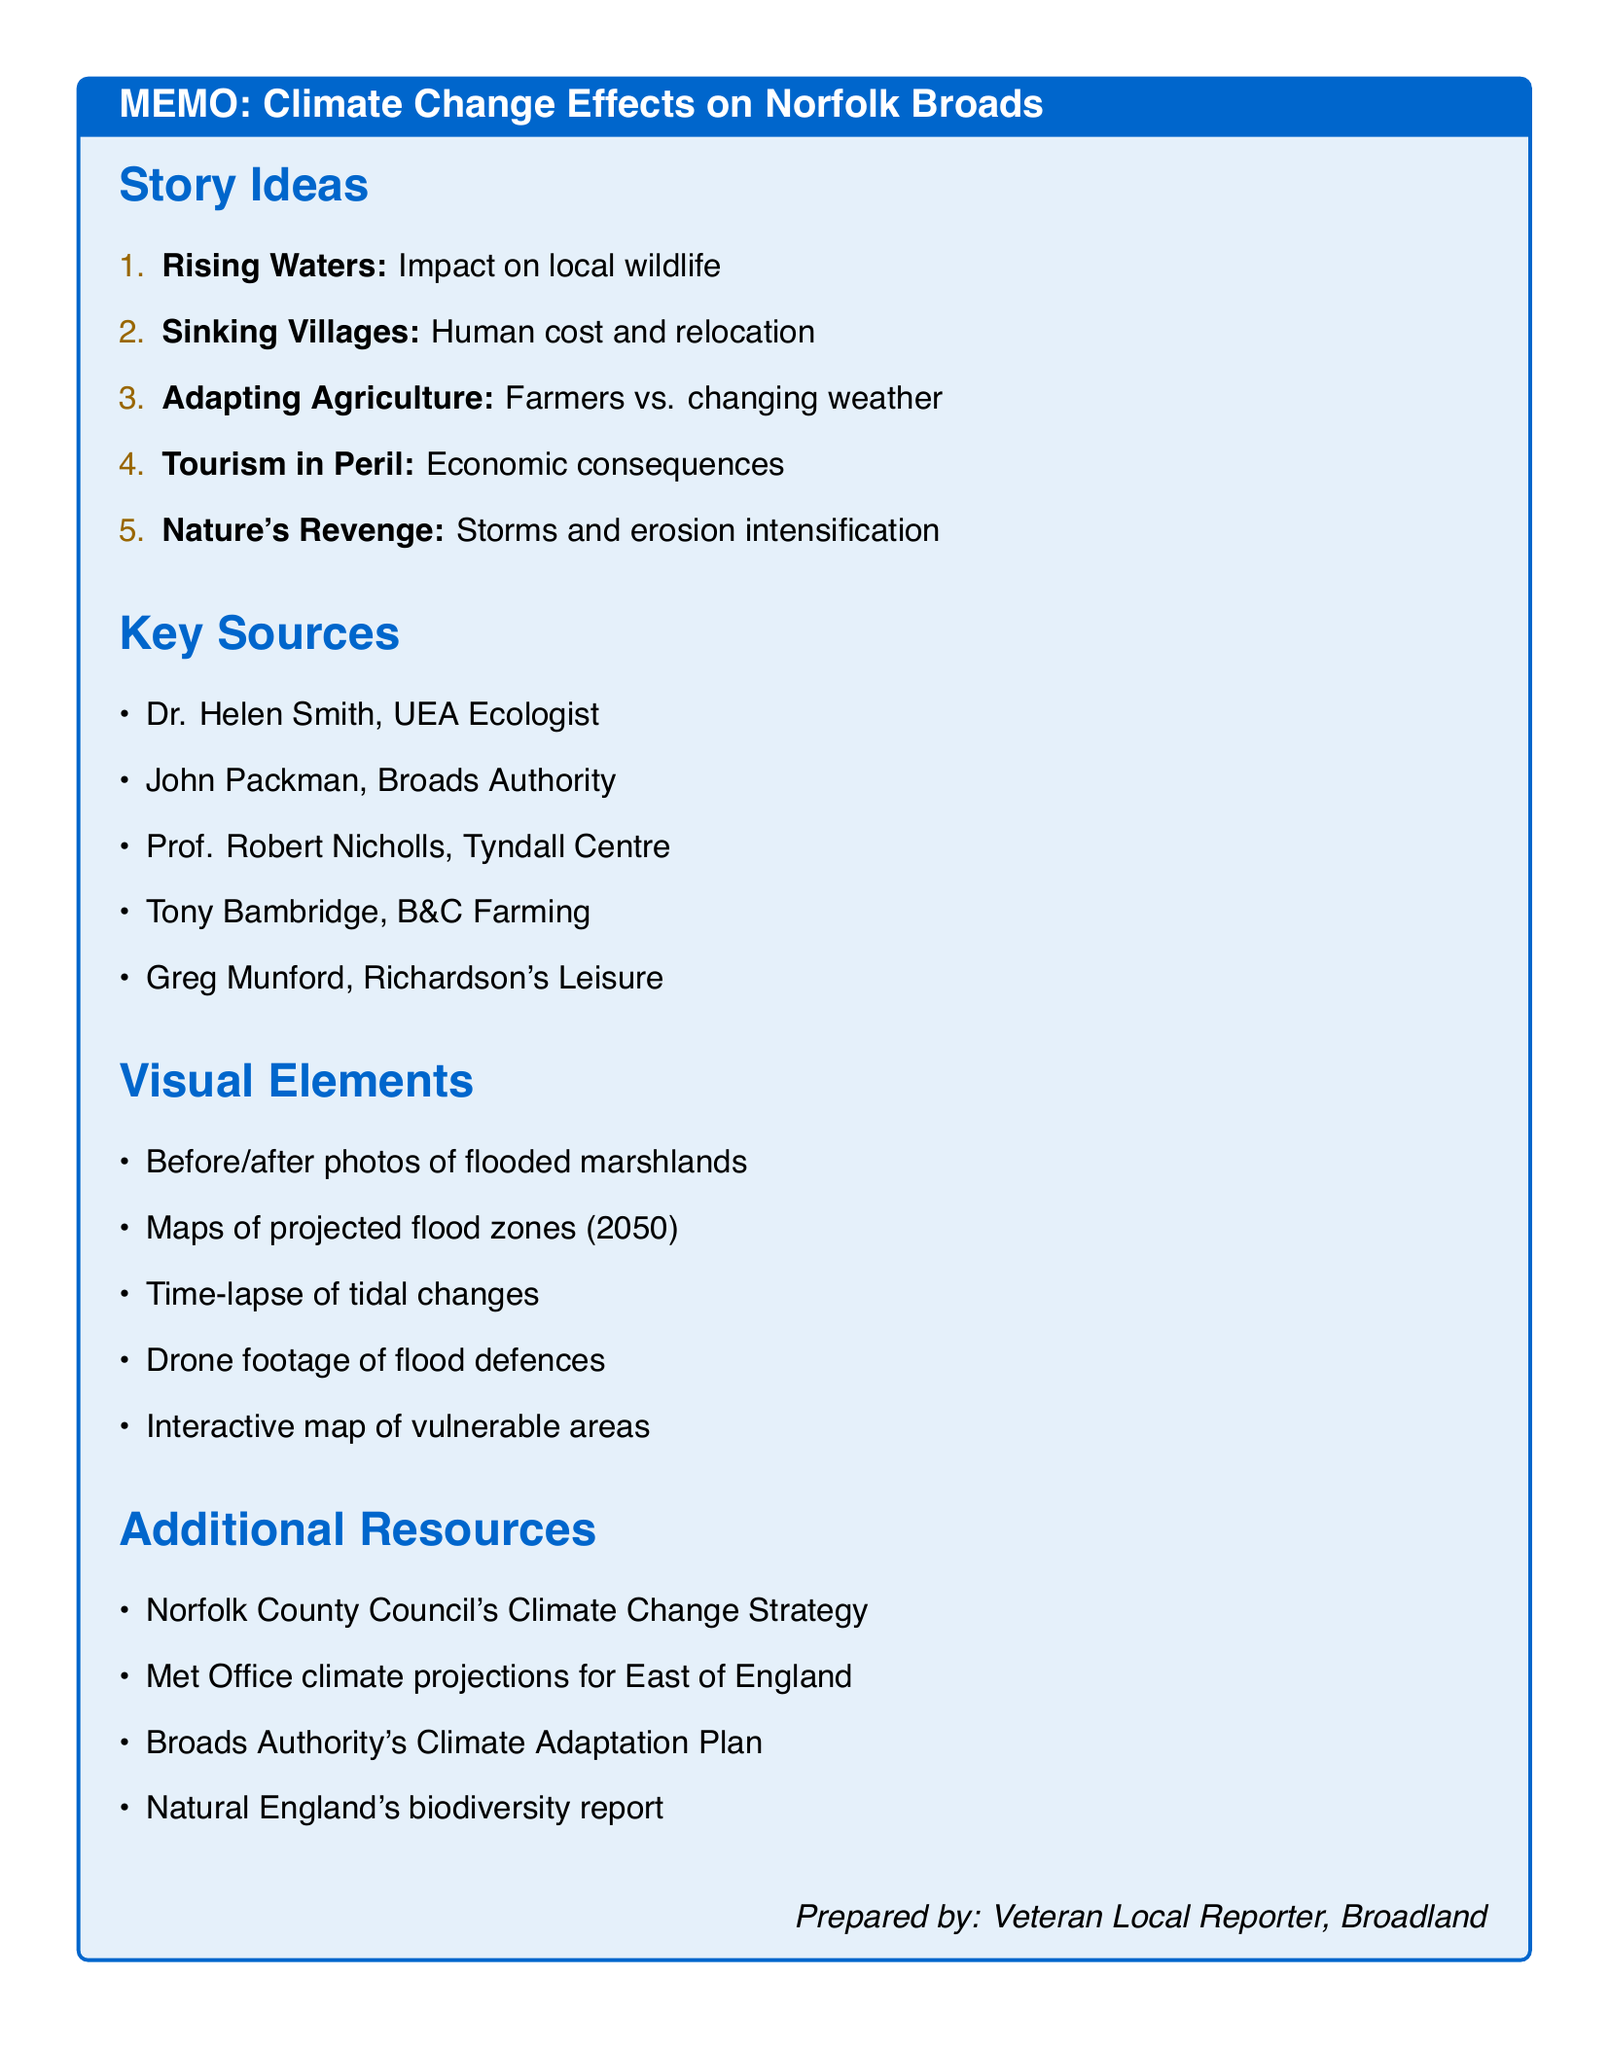What is the title of the first story idea? The title of the first story idea is found in the list of story ideas in the document.
Answer: Rising Waters: The Threat to Norfolk Broads' Wildlife How many key sources are listed in the memo? The number of key sources can be counted in the "Key Sources" section of the memo.
Answer: 5 Who is the Chief Executive of the Broads Authority? The Chief Executive of the Broads Authority is mentioned in the list of sources for the first story idea.
Answer: John Packman What visual element is suggested for showing flooding effects? A visual element that addresses flooding effects can be found in the "Visual Elements" section.
Answer: Before and after photos of flooded marshlands Which story idea focuses on the economic impact of climate change? The economic impact story is indicated within the titles of the story ideas section.
Answer: Tourism in Peril: The Economic Impact of Climate Change on the Broads What additional resource discusses biodiversity in the Norfolk Broads? The additional resources section mentions a report related to biodiversity in the Broads.
Answer: Natural England's report on biodiversity in the Norfolk Broads Which visual element involves technology for risk mapping? The technology for risk mapping can be identified in the list of visual elements that provide insights into vulnerable areas.
Answer: Interactive map of the Norfolk Broads showing vulnerable areas Who is a potential interviewee from the local fishing community? The potential interviewees list includes individuals related to the fishing community.
Answer: Anglers and recreational fishermen 